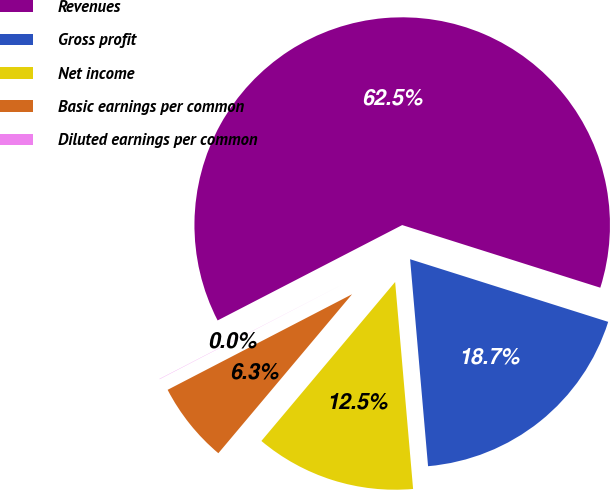Convert chart to OTSL. <chart><loc_0><loc_0><loc_500><loc_500><pie_chart><fcel>Revenues<fcel>Gross profit<fcel>Net income<fcel>Basic earnings per common<fcel>Diluted earnings per common<nl><fcel>62.47%<fcel>18.75%<fcel>12.51%<fcel>6.26%<fcel>0.02%<nl></chart> 